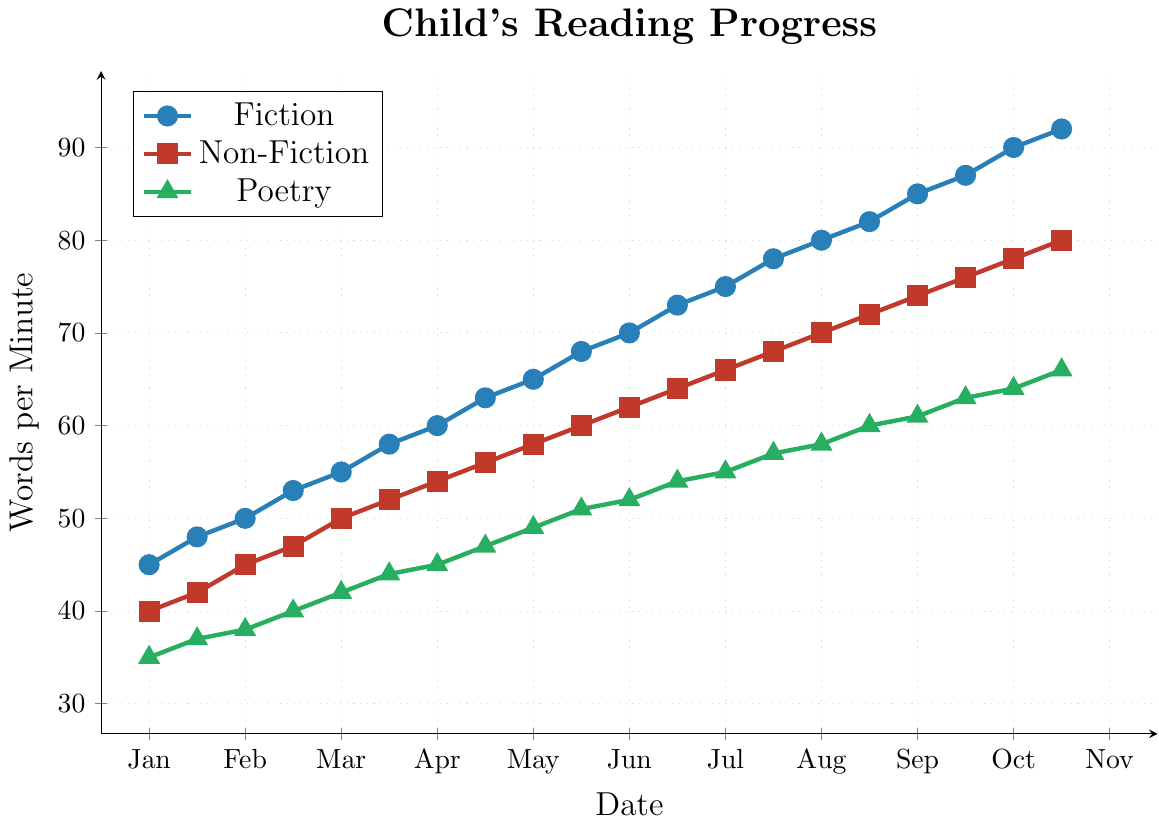What is the difference in words per minute between Fiction and Non-Fiction on 2023-10-01? On the date 2023-10-01, Fiction has 87 words per minute and Non-Fiction has 76 words per minute. The difference is calculated as 87 - 76.
Answer: 11 Which category shows the most improvement from 2023-01-15 to 2023-11-01? To determine the most improvement, we calculate the difference in words per minute for each category between 2023-01-15 and 2023-11-01. Fiction improves from 45 to 92, a difference of 47. Non-Fiction improves from 40 to 80, a difference of 40. Poetry improves from 35 to 66, a difference of 31. The greatest improvement is in Fiction.
Answer: Fiction On which date do Poetry and Non-Fiction have the same words per minute? By examining the chart, on all dates Poetry always has fewer words per minute compared to Non-Fiction since no dates have marks at the same level. Therefore, there's no single date when Poetry and Non-Fiction converge to the same words per minute.
Answer: Never What is the average words per minute for Fiction in the last three recorded dates? The words per minute for Fiction on the last three dates (2023-10-15, 2023-11-01, and 2023-09-15) are 90, 92, and 87 respectively. The average is calculated as (90 + 92 + 87) / 3.
Answer: 89.67 By how much did Fiction outpace Poetry on 2023-09-15? On 2023-09-15, Fiction had 85 words per minute, while Poetry had 61 words per minute. The difference is found by subtracting 61 from 85.
Answer: 24 Which category surpassed 50 words per minute first, and when did this occur? By checking the plotted points, Non-Fiction surpassed 50 words per minute first on 2023-03-15 (reached 50 words per minute), while Fiction reached 50 words per minute on 2023-02-15.
Answer: Fiction on 2023-02-15 What is the range of words per minute for Non-Fiction over the entire period? To find the range, we subtract the minimum words per minute from the maximum words per minute for Non-Fiction. The range is 80 (maximum) - 40 (minimum).
Answer: 40 What is the visual difference in slope between Fiction and Poetry from 2023-01-15 to 2023-04-01? The slope or steepness visually observed from 2023-01-15 to 2023-04-01 shows that Fiction rises more sharply compared to Poetry. Fiction increases from 45 to 58 (steep slope), while Poetry rises more gently from 35 to 44.
Answer: Fiction has a steeper slope How many months did it take for Fiction to achieve more than twice the words per minute over Poetry? Twice the starting value for Poetry is 70 words per minute (2 * 35). Fiction achieved 70 words per minute on 2023-06-15, starting from 2023-01-15. The difference in time between these dates is 5 months.
Answer: 5 months 